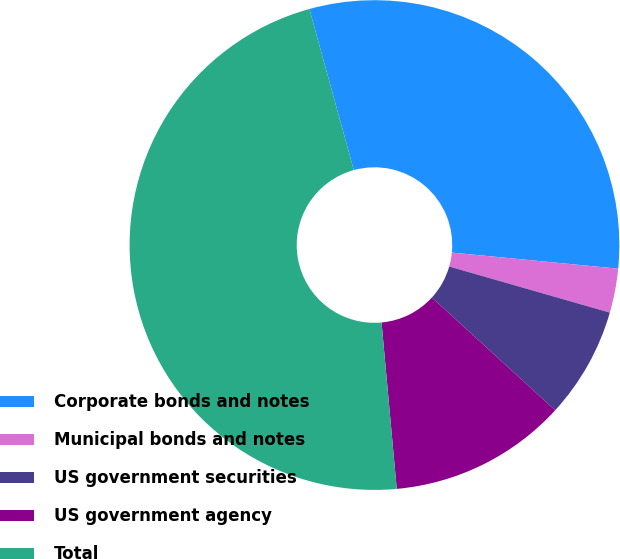Convert chart to OTSL. <chart><loc_0><loc_0><loc_500><loc_500><pie_chart><fcel>Corporate bonds and notes<fcel>Municipal bonds and notes<fcel>US government securities<fcel>US government agency<fcel>Total<nl><fcel>30.82%<fcel>2.91%<fcel>7.34%<fcel>11.76%<fcel>47.17%<nl></chart> 